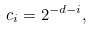Convert formula to latex. <formula><loc_0><loc_0><loc_500><loc_500>c _ { i } = 2 ^ { - d - i } ,</formula> 